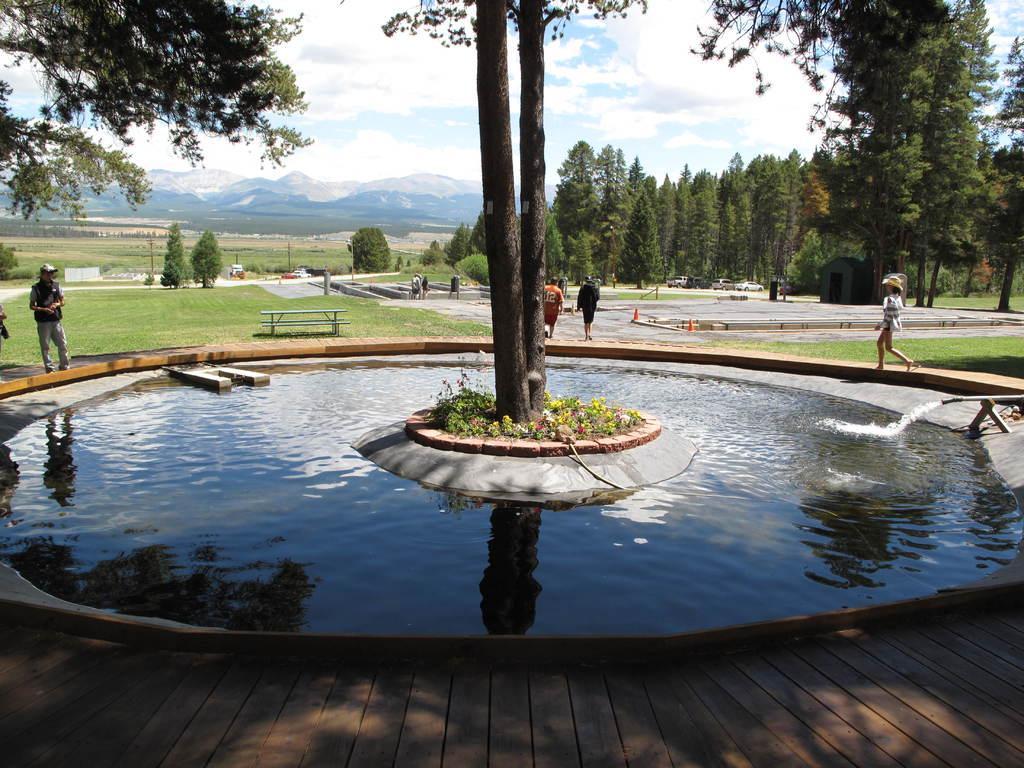Can you describe this image briefly? We can see water, pipe, trees, plants and flowers. There are people and we can see table, benches and grass. In the background we can trees, hills and sky. 